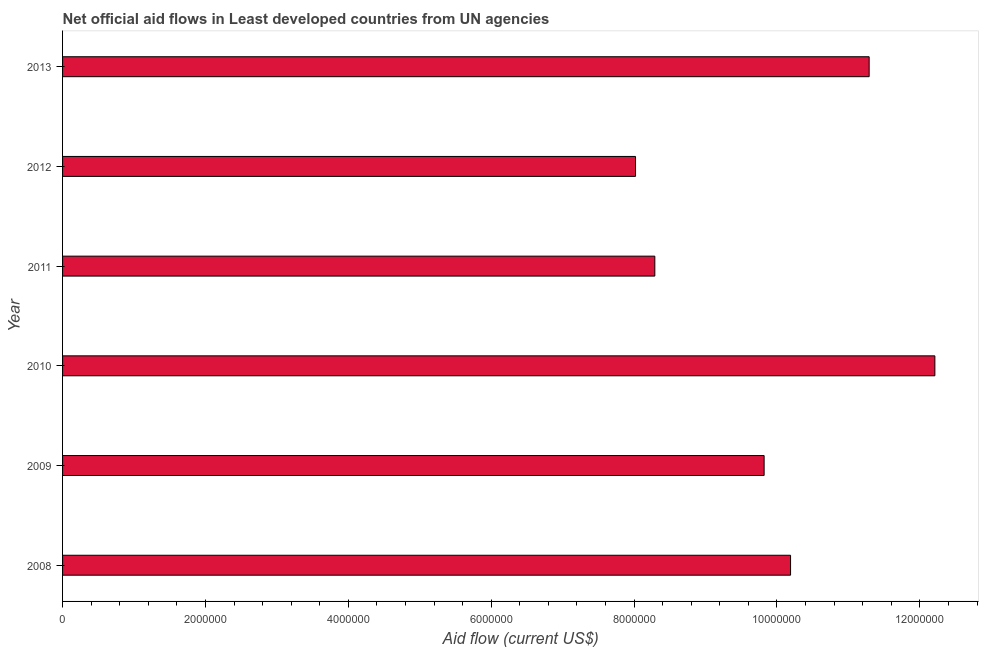Does the graph contain grids?
Give a very brief answer. No. What is the title of the graph?
Make the answer very short. Net official aid flows in Least developed countries from UN agencies. What is the label or title of the X-axis?
Make the answer very short. Aid flow (current US$). What is the net official flows from un agencies in 2013?
Offer a very short reply. 1.13e+07. Across all years, what is the maximum net official flows from un agencies?
Provide a short and direct response. 1.22e+07. Across all years, what is the minimum net official flows from un agencies?
Provide a succinct answer. 8.02e+06. In which year was the net official flows from un agencies maximum?
Your answer should be compact. 2010. What is the sum of the net official flows from un agencies?
Offer a terse response. 5.98e+07. What is the difference between the net official flows from un agencies in 2009 and 2011?
Ensure brevity in your answer.  1.53e+06. What is the average net official flows from un agencies per year?
Provide a short and direct response. 9.97e+06. What is the median net official flows from un agencies?
Provide a succinct answer. 1.00e+07. In how many years, is the net official flows from un agencies greater than 4400000 US$?
Make the answer very short. 6. Do a majority of the years between 2008 and 2010 (inclusive) have net official flows from un agencies greater than 2000000 US$?
Keep it short and to the point. Yes. What is the ratio of the net official flows from un agencies in 2009 to that in 2012?
Your answer should be very brief. 1.22. Is the net official flows from un agencies in 2008 less than that in 2012?
Ensure brevity in your answer.  No. What is the difference between the highest and the second highest net official flows from un agencies?
Offer a terse response. 9.20e+05. What is the difference between the highest and the lowest net official flows from un agencies?
Your answer should be very brief. 4.19e+06. In how many years, is the net official flows from un agencies greater than the average net official flows from un agencies taken over all years?
Ensure brevity in your answer.  3. How many years are there in the graph?
Offer a terse response. 6. Are the values on the major ticks of X-axis written in scientific E-notation?
Make the answer very short. No. What is the Aid flow (current US$) of 2008?
Your response must be concise. 1.02e+07. What is the Aid flow (current US$) of 2009?
Provide a succinct answer. 9.82e+06. What is the Aid flow (current US$) in 2010?
Ensure brevity in your answer.  1.22e+07. What is the Aid flow (current US$) of 2011?
Offer a terse response. 8.29e+06. What is the Aid flow (current US$) of 2012?
Give a very brief answer. 8.02e+06. What is the Aid flow (current US$) in 2013?
Ensure brevity in your answer.  1.13e+07. What is the difference between the Aid flow (current US$) in 2008 and 2010?
Offer a very short reply. -2.02e+06. What is the difference between the Aid flow (current US$) in 2008 and 2011?
Your answer should be very brief. 1.90e+06. What is the difference between the Aid flow (current US$) in 2008 and 2012?
Offer a very short reply. 2.17e+06. What is the difference between the Aid flow (current US$) in 2008 and 2013?
Provide a succinct answer. -1.10e+06. What is the difference between the Aid flow (current US$) in 2009 and 2010?
Keep it short and to the point. -2.39e+06. What is the difference between the Aid flow (current US$) in 2009 and 2011?
Make the answer very short. 1.53e+06. What is the difference between the Aid flow (current US$) in 2009 and 2012?
Offer a terse response. 1.80e+06. What is the difference between the Aid flow (current US$) in 2009 and 2013?
Make the answer very short. -1.47e+06. What is the difference between the Aid flow (current US$) in 2010 and 2011?
Provide a succinct answer. 3.92e+06. What is the difference between the Aid flow (current US$) in 2010 and 2012?
Offer a very short reply. 4.19e+06. What is the difference between the Aid flow (current US$) in 2010 and 2013?
Your answer should be compact. 9.20e+05. What is the difference between the Aid flow (current US$) in 2011 and 2012?
Give a very brief answer. 2.70e+05. What is the difference between the Aid flow (current US$) in 2011 and 2013?
Your response must be concise. -3.00e+06. What is the difference between the Aid flow (current US$) in 2012 and 2013?
Give a very brief answer. -3.27e+06. What is the ratio of the Aid flow (current US$) in 2008 to that in 2009?
Your answer should be compact. 1.04. What is the ratio of the Aid flow (current US$) in 2008 to that in 2010?
Offer a very short reply. 0.83. What is the ratio of the Aid flow (current US$) in 2008 to that in 2011?
Your answer should be compact. 1.23. What is the ratio of the Aid flow (current US$) in 2008 to that in 2012?
Your answer should be very brief. 1.27. What is the ratio of the Aid flow (current US$) in 2008 to that in 2013?
Ensure brevity in your answer.  0.9. What is the ratio of the Aid flow (current US$) in 2009 to that in 2010?
Make the answer very short. 0.8. What is the ratio of the Aid flow (current US$) in 2009 to that in 2011?
Your response must be concise. 1.19. What is the ratio of the Aid flow (current US$) in 2009 to that in 2012?
Ensure brevity in your answer.  1.22. What is the ratio of the Aid flow (current US$) in 2009 to that in 2013?
Your response must be concise. 0.87. What is the ratio of the Aid flow (current US$) in 2010 to that in 2011?
Give a very brief answer. 1.47. What is the ratio of the Aid flow (current US$) in 2010 to that in 2012?
Your response must be concise. 1.52. What is the ratio of the Aid flow (current US$) in 2010 to that in 2013?
Offer a terse response. 1.08. What is the ratio of the Aid flow (current US$) in 2011 to that in 2012?
Keep it short and to the point. 1.03. What is the ratio of the Aid flow (current US$) in 2011 to that in 2013?
Ensure brevity in your answer.  0.73. What is the ratio of the Aid flow (current US$) in 2012 to that in 2013?
Your answer should be compact. 0.71. 